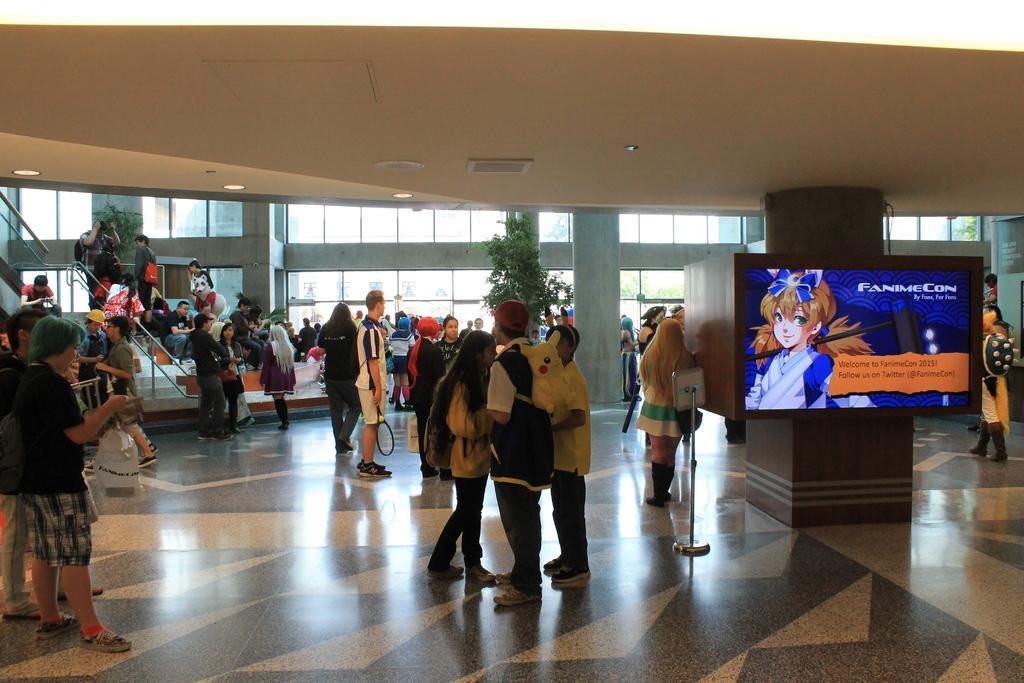How would you summarize this image in a sentence or two? In this image I can see number of persons standing on the floor, a television screen, a pillar, few trees, few stairs, the ceiling and the glass windows through which I can see few trees and the sky. 